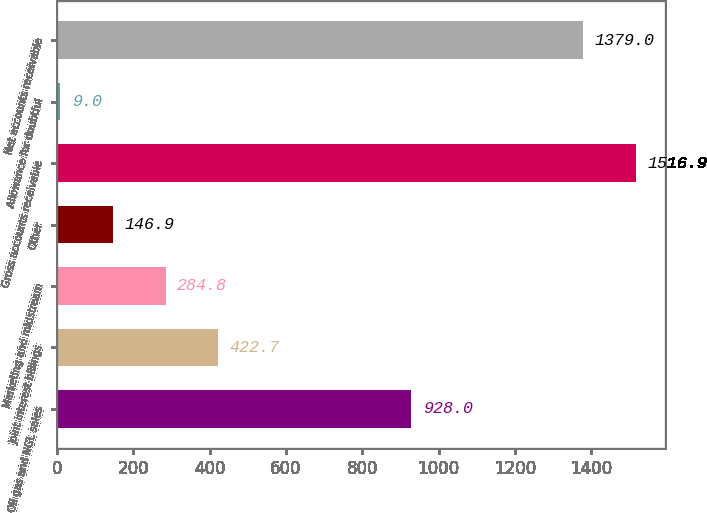Convert chart. <chart><loc_0><loc_0><loc_500><loc_500><bar_chart><fcel>Oil gas and NGL sales<fcel>Joint interest billings<fcel>Marketing and midstream<fcel>Other<fcel>Gross accounts receivable<fcel>Allowance for doubtful<fcel>Net accounts receivable<nl><fcel>928<fcel>422.7<fcel>284.8<fcel>146.9<fcel>1516.9<fcel>9<fcel>1379<nl></chart> 